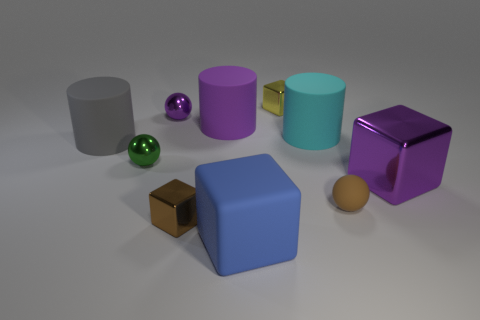Is the number of tiny cyan cylinders greater than the number of cylinders?
Your answer should be compact. No. Are there any other things that are the same color as the rubber block?
Make the answer very short. No. What shape is the tiny brown thing that is made of the same material as the small green thing?
Ensure brevity in your answer.  Cube. What is the material of the tiny sphere to the right of the tiny block that is to the right of the tiny brown cube?
Offer a very short reply. Rubber. Is the shape of the tiny object in front of the brown sphere the same as  the tiny yellow shiny thing?
Your response must be concise. Yes. Are there more big rubber cylinders that are on the left side of the purple shiny sphere than cyan metal cylinders?
Keep it short and to the point. Yes. What is the shape of the matte thing that is the same color as the large metal thing?
Keep it short and to the point. Cylinder. What number of cylinders are small shiny objects or purple matte things?
Provide a short and direct response. 1. The rubber cylinder that is to the right of the large cube that is in front of the brown sphere is what color?
Keep it short and to the point. Cyan. There is a big metallic object; is it the same color as the sphere that is behind the purple rubber cylinder?
Offer a terse response. Yes. 